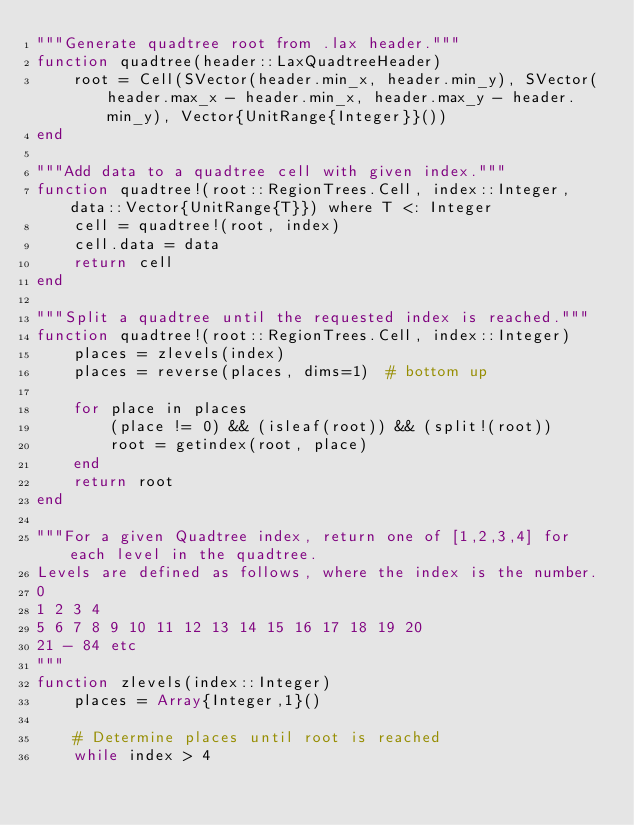<code> <loc_0><loc_0><loc_500><loc_500><_Julia_>"""Generate quadtree root from .lax header."""
function quadtree(header::LaxQuadtreeHeader)
    root = Cell(SVector(header.min_x, header.min_y), SVector(header.max_x - header.min_x, header.max_y - header.min_y), Vector{UnitRange{Integer}}())
end

"""Add data to a quadtree cell with given index."""
function quadtree!(root::RegionTrees.Cell, index::Integer, data::Vector{UnitRange{T}}) where T <: Integer
    cell = quadtree!(root, index)
    cell.data = data
    return cell
end

"""Split a quadtree until the requested index is reached."""
function quadtree!(root::RegionTrees.Cell, index::Integer)
    places = zlevels(index)
    places = reverse(places, dims=1)  # bottom up

    for place in places
        (place != 0) && (isleaf(root)) && (split!(root))
        root = getindex(root, place)
    end
    return root
end

"""For a given Quadtree index, return one of [1,2,3,4] for each level in the quadtree.
Levels are defined as follows, where the index is the number. 
0
1 2 3 4
5 6 7 8 9 10 11 12 13 14 15 16 17 18 19 20
21 - 84 etc
"""
function zlevels(index::Integer)
    places = Array{Integer,1}()
    
    # Determine places until root is reached
    while index > 4
</code> 